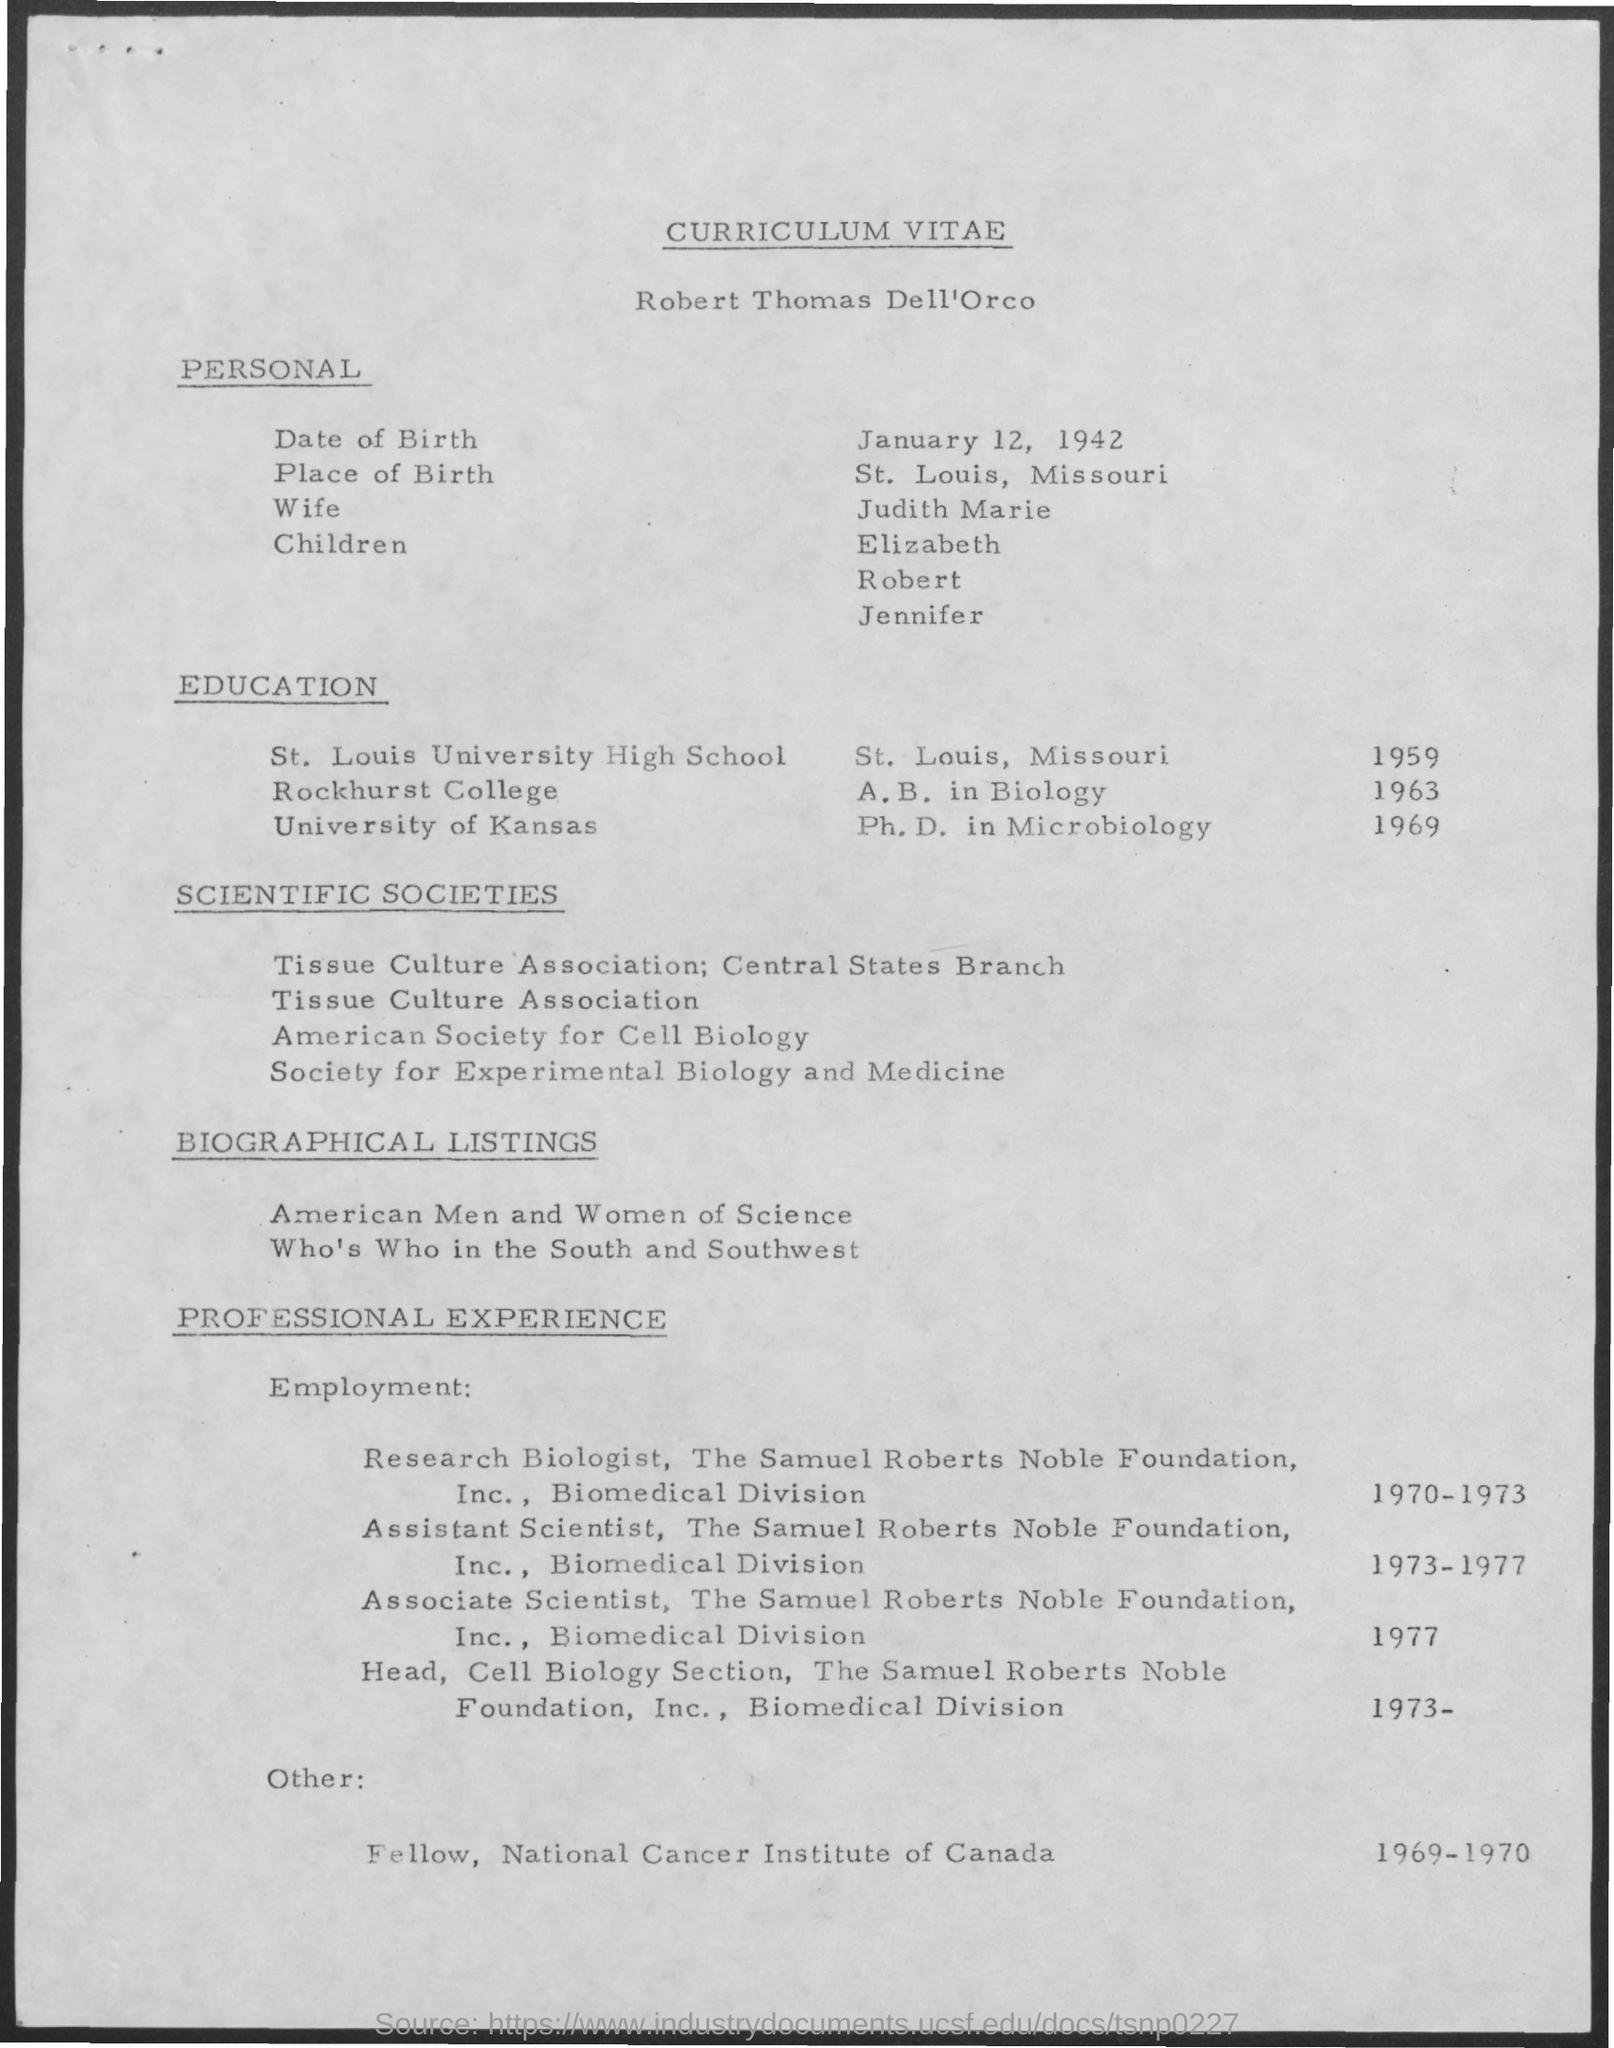Indicate a few pertinent items in this graphic. The title of the document is a Curriculum Vitae. The date of birth of the person in question is January 12, 1942. Judith Marie is the wife. The place of birth of the individual in question is St. Louis, Missouri. 